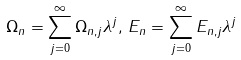Convert formula to latex. <formula><loc_0><loc_0><loc_500><loc_500>\Omega _ { n } = \sum ^ { \infty } _ { j = 0 } \Omega _ { n , j } \lambda ^ { j } , \, E _ { n } = \sum ^ { \infty } _ { j = 0 } E _ { n , j } \lambda ^ { j }</formula> 